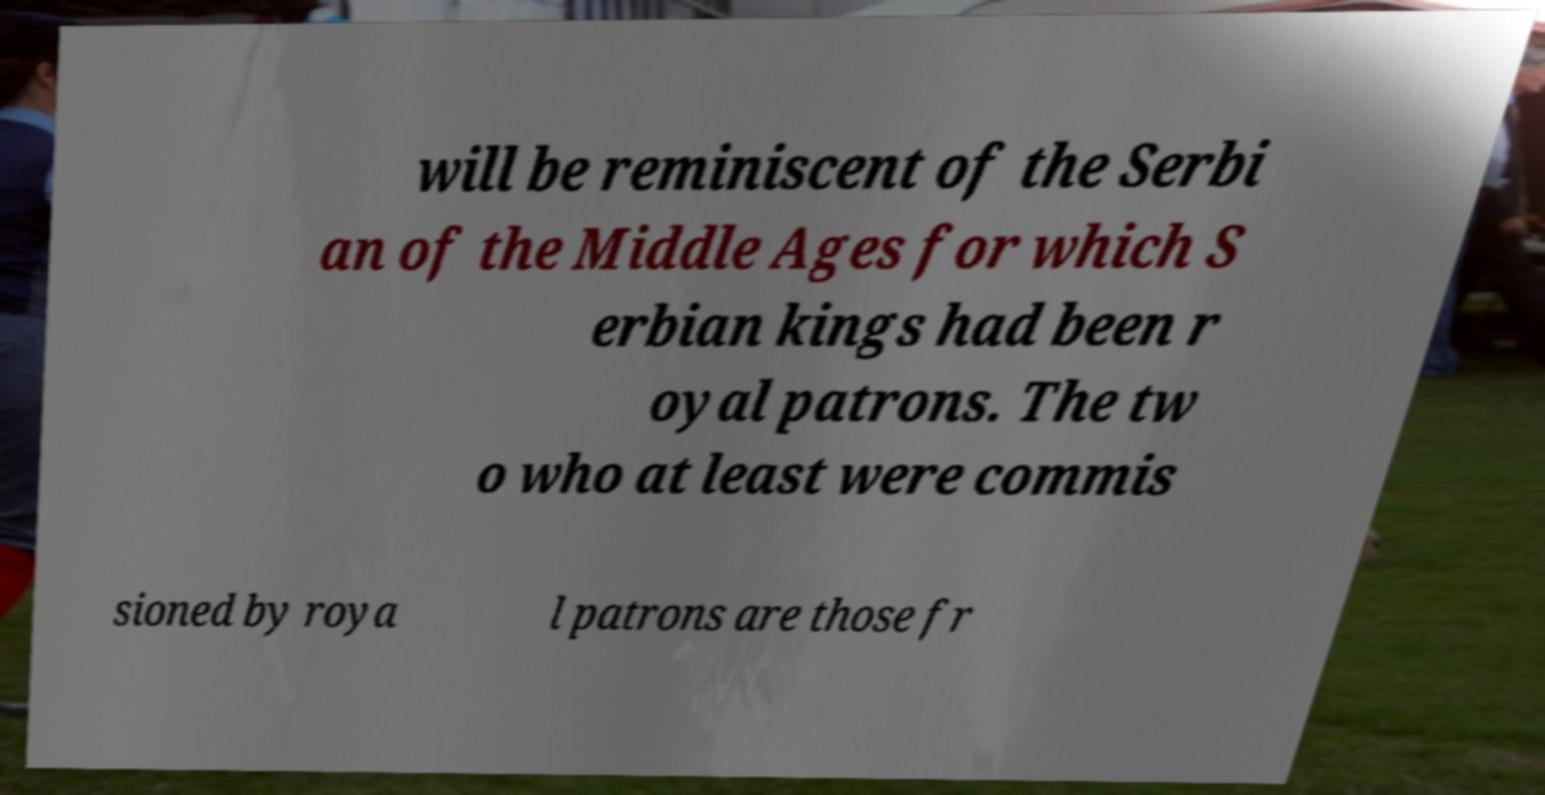Please read and relay the text visible in this image. What does it say? will be reminiscent of the Serbi an of the Middle Ages for which S erbian kings had been r oyal patrons. The tw o who at least were commis sioned by roya l patrons are those fr 